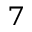Convert formula to latex. <formula><loc_0><loc_0><loc_500><loc_500>^ { 7 }</formula> 